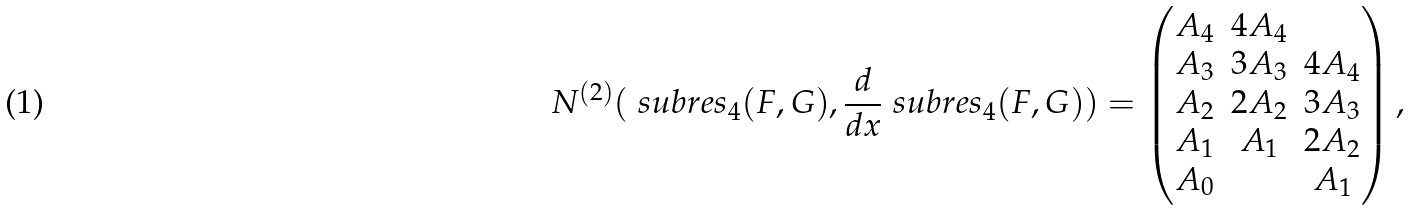Convert formula to latex. <formula><loc_0><loc_0><loc_500><loc_500>N ^ { ( 2 ) } ( \ s u b r e s _ { 4 } ( F , G ) , \frac { d } { d x } \ s u b r e s _ { 4 } ( F , G ) ) = \begin{pmatrix} A _ { 4 } & 4 A _ { 4 } & \\ A _ { 3 } & 3 A _ { 3 } & 4 A _ { 4 } \\ A _ { 2 } & 2 A _ { 2 } & 3 A _ { 3 } \\ A _ { 1 } & A _ { 1 } & 2 A _ { 2 } \\ A _ { 0 } & & A _ { 1 } \end{pmatrix} ,</formula> 